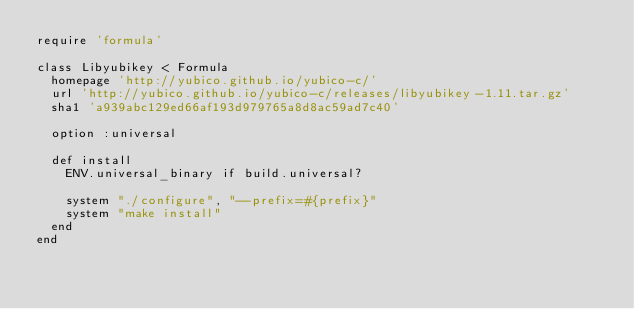Convert code to text. <code><loc_0><loc_0><loc_500><loc_500><_Ruby_>require 'formula'

class Libyubikey < Formula
  homepage 'http://yubico.github.io/yubico-c/'
  url 'http://yubico.github.io/yubico-c/releases/libyubikey-1.11.tar.gz'
  sha1 'a939abc129ed66af193d979765a8d8ac59ad7c40'

  option :universal

  def install
    ENV.universal_binary if build.universal?

    system "./configure", "--prefix=#{prefix}"
    system "make install"
  end
end
</code> 